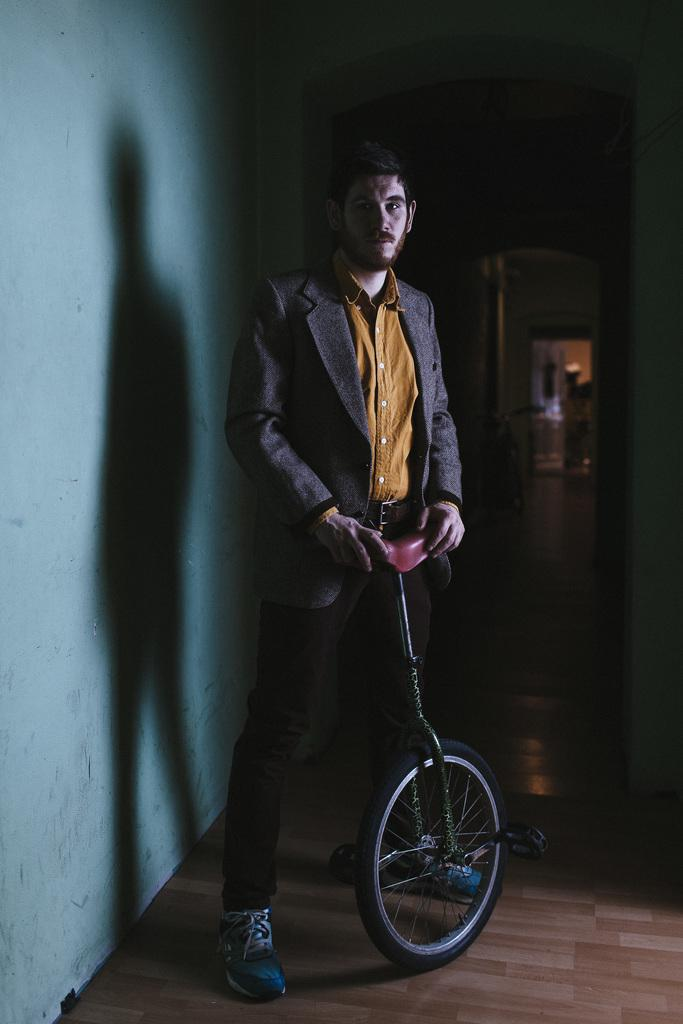Who is present in the image? There is a man in the image. What is the man holding in the image? The man is holding a cycle. What is located beside the man in the image? There is a wall beside the man. How would you describe the overall lighting in the image? The background of the image is dark. What type of jam is the man eating in the image? There is no jam present in the image; the man is holding a cycle. Can you see a monkey climbing on the wall in the image? There is no monkey present in the image; only the man, the cycle, and the wall are visible. 